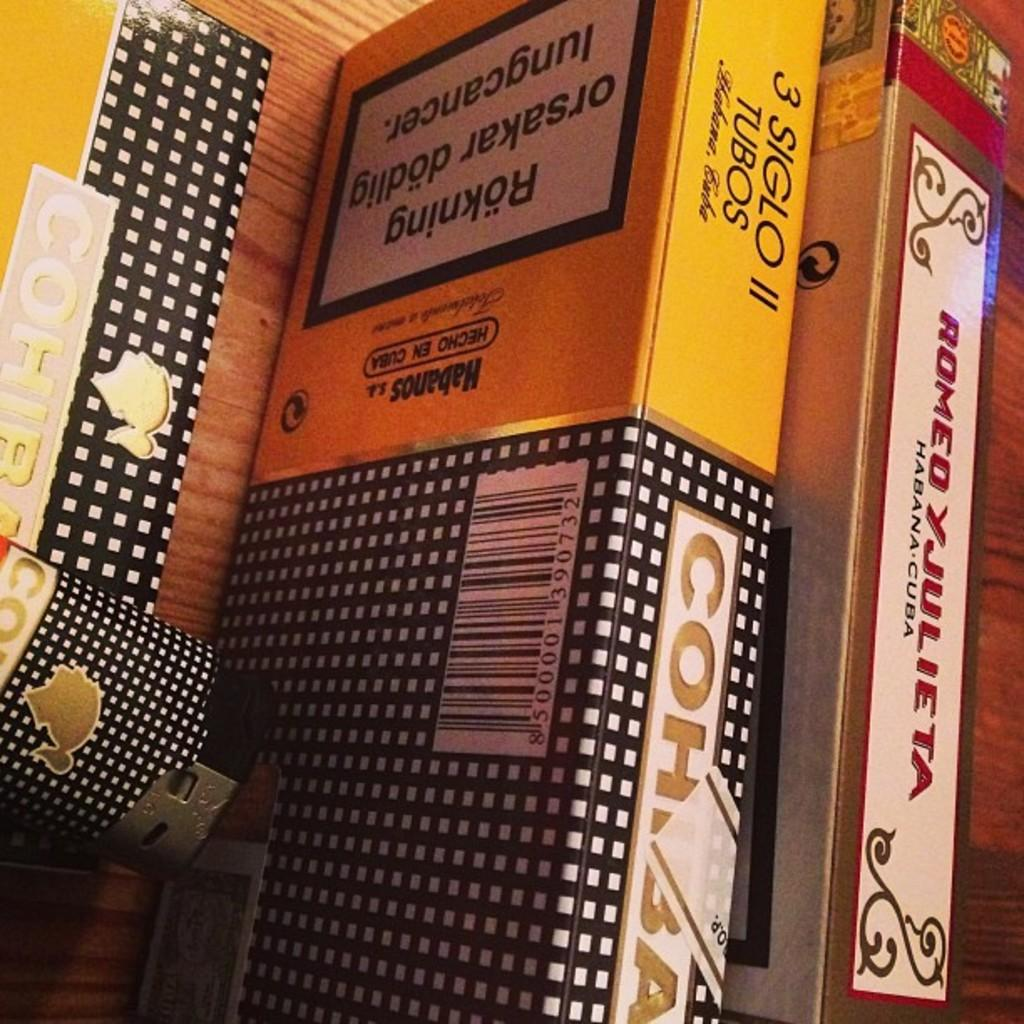What type of objects can be seen in the image? There are books in the image. How can the books be distinguished from one another? The books have different names and colors. Where are the books located in the image? The books are placed on a shelf. What type of insect can be seen crawling on the books in the image? There are no insects present in the image; it only features books on a shelf. 